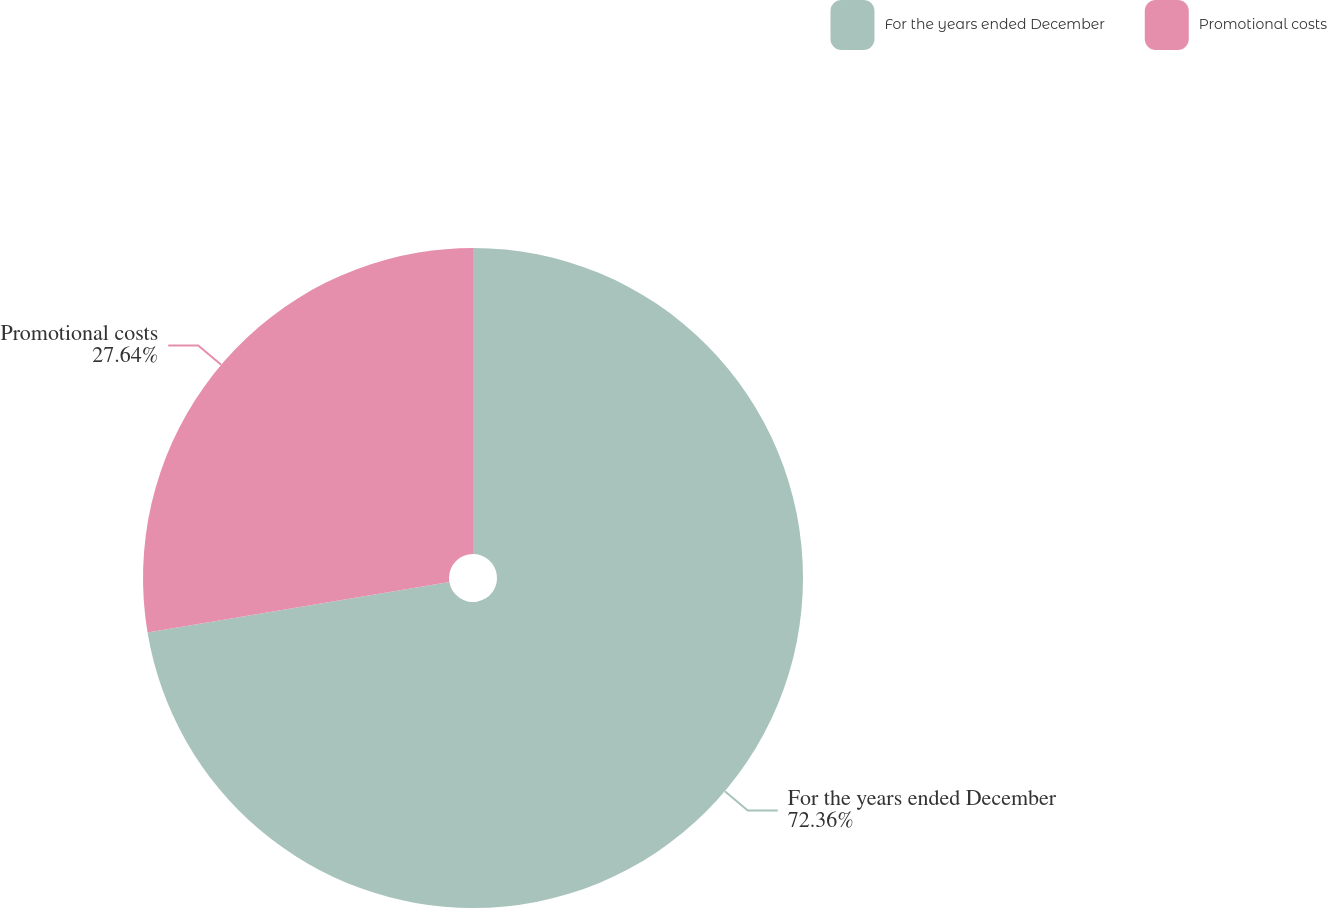Convert chart to OTSL. <chart><loc_0><loc_0><loc_500><loc_500><pie_chart><fcel>For the years ended December<fcel>Promotional costs<nl><fcel>72.36%<fcel>27.64%<nl></chart> 